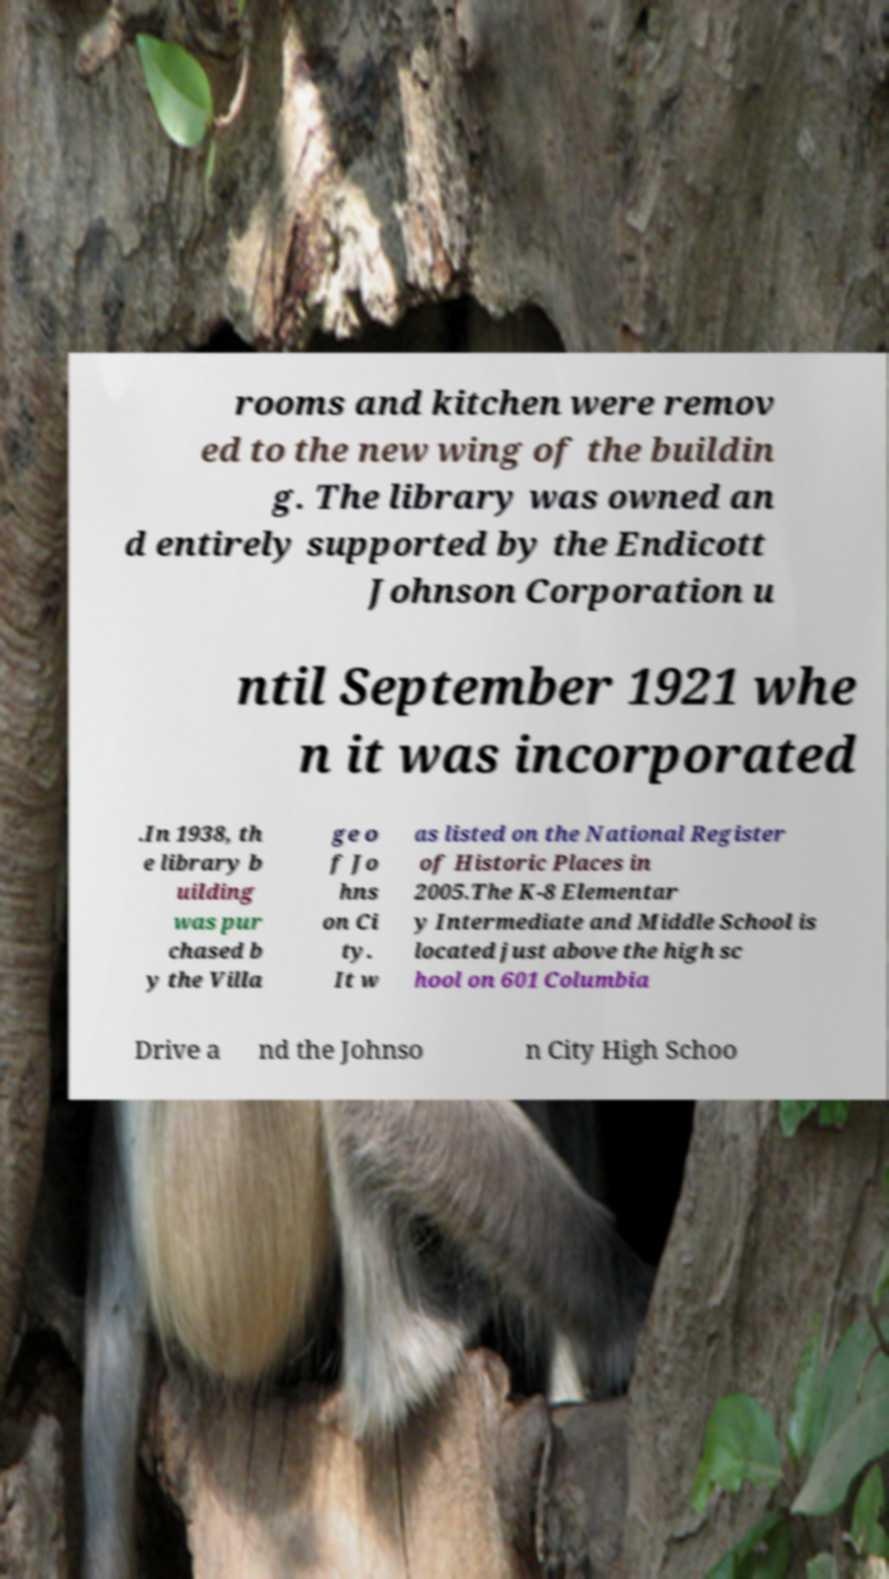What messages or text are displayed in this image? I need them in a readable, typed format. rooms and kitchen were remov ed to the new wing of the buildin g. The library was owned an d entirely supported by the Endicott Johnson Corporation u ntil September 1921 whe n it was incorporated .In 1938, th e library b uilding was pur chased b y the Villa ge o f Jo hns on Ci ty. It w as listed on the National Register of Historic Places in 2005.The K-8 Elementar y Intermediate and Middle School is located just above the high sc hool on 601 Columbia Drive a nd the Johnso n City High Schoo 